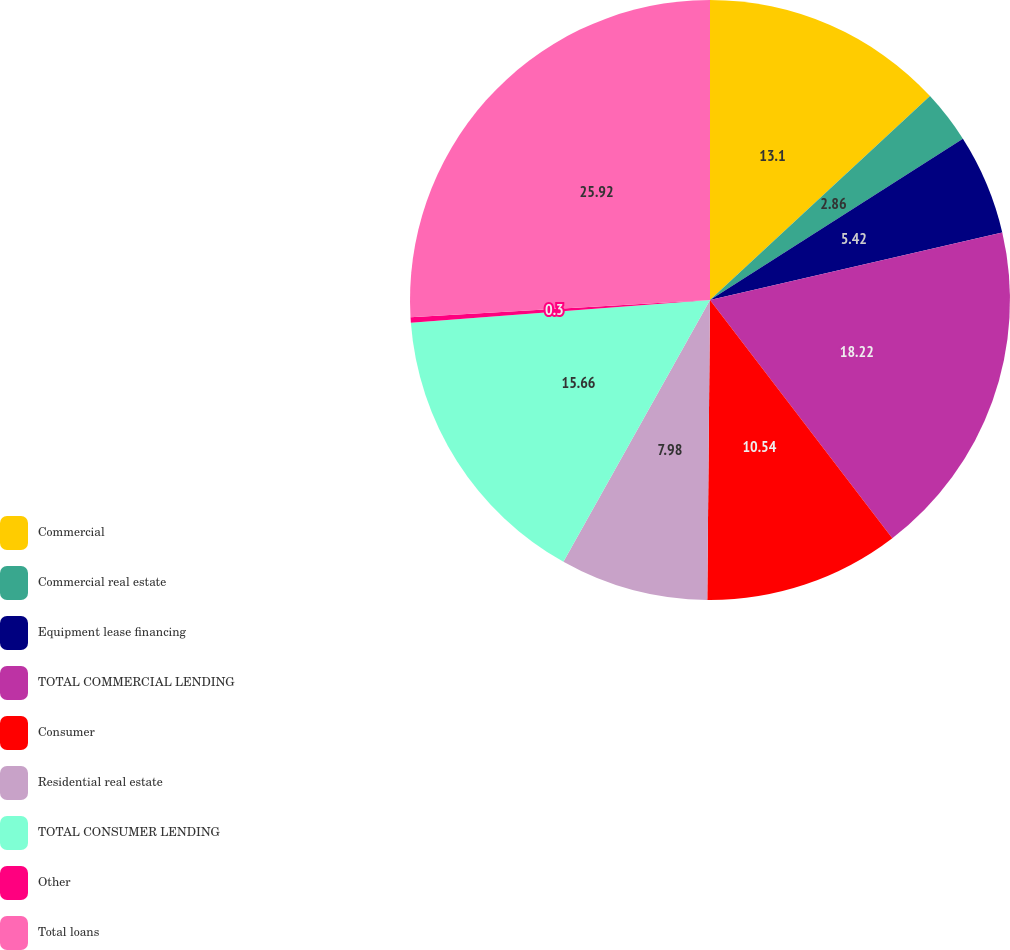Convert chart to OTSL. <chart><loc_0><loc_0><loc_500><loc_500><pie_chart><fcel>Commercial<fcel>Commercial real estate<fcel>Equipment lease financing<fcel>TOTAL COMMERCIAL LENDING<fcel>Consumer<fcel>Residential real estate<fcel>TOTAL CONSUMER LENDING<fcel>Other<fcel>Total loans<nl><fcel>13.1%<fcel>2.86%<fcel>5.42%<fcel>18.22%<fcel>10.54%<fcel>7.98%<fcel>15.66%<fcel>0.3%<fcel>25.91%<nl></chart> 